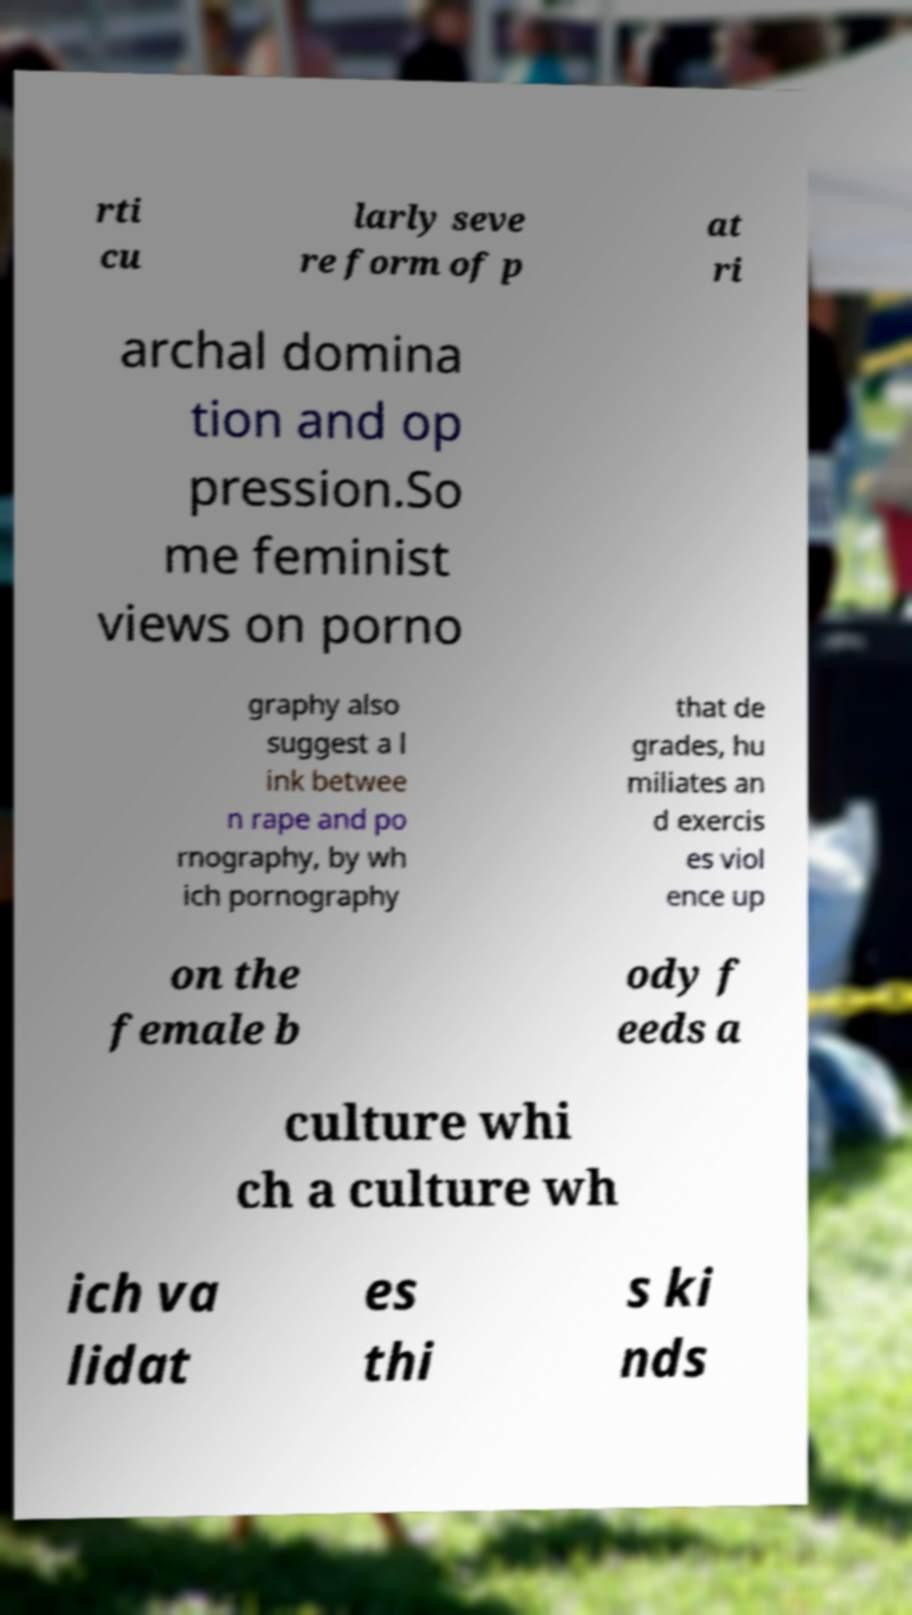For documentation purposes, I need the text within this image transcribed. Could you provide that? rti cu larly seve re form of p at ri archal domina tion and op pression.So me feminist views on porno graphy also suggest a l ink betwee n rape and po rnography, by wh ich pornography that de grades, hu miliates an d exercis es viol ence up on the female b ody f eeds a culture whi ch a culture wh ich va lidat es thi s ki nds 